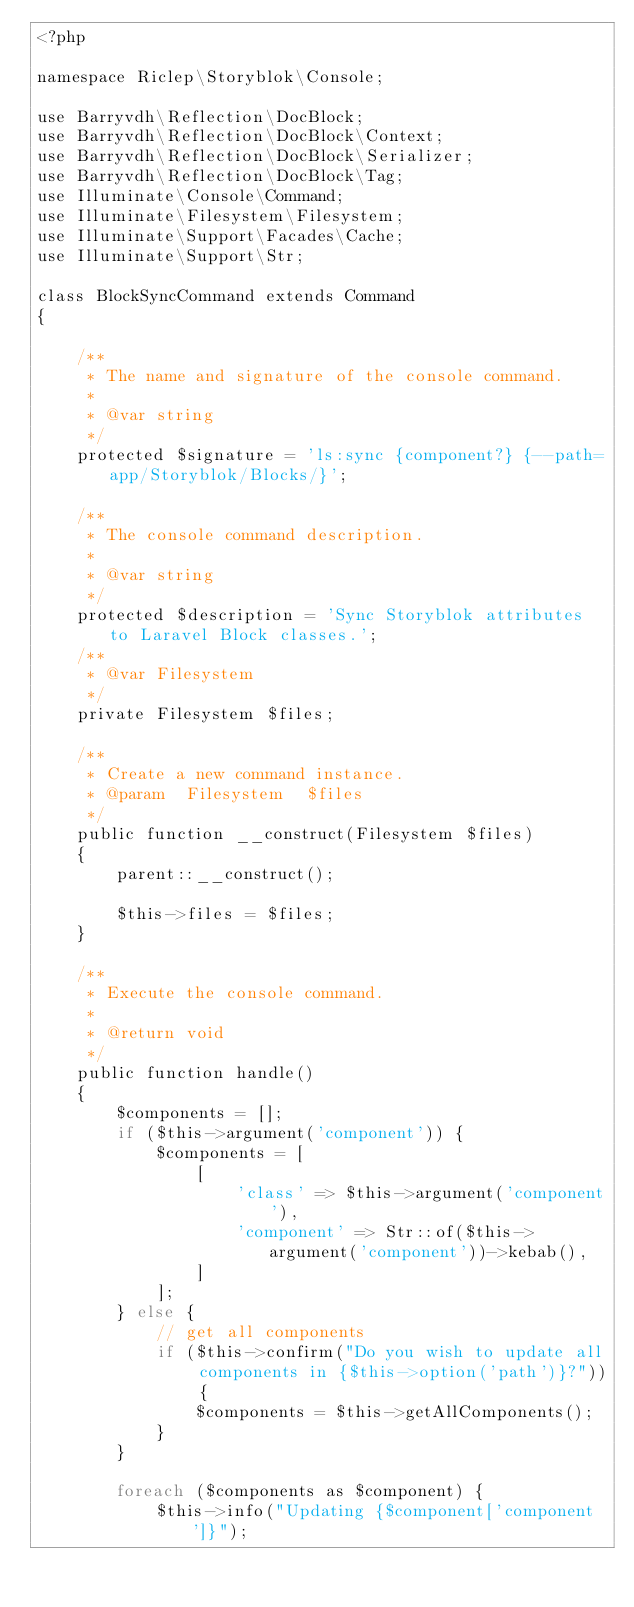<code> <loc_0><loc_0><loc_500><loc_500><_PHP_><?php

namespace Riclep\Storyblok\Console;

use Barryvdh\Reflection\DocBlock;
use Barryvdh\Reflection\DocBlock\Context;
use Barryvdh\Reflection\DocBlock\Serializer;
use Barryvdh\Reflection\DocBlock\Tag;
use Illuminate\Console\Command;
use Illuminate\Filesystem\Filesystem;
use Illuminate\Support\Facades\Cache;
use Illuminate\Support\Str;

class BlockSyncCommand extends Command
{

    /**
     * The name and signature of the console command.
     *
     * @var string
     */
    protected $signature = 'ls:sync {component?} {--path=app/Storyblok/Blocks/}';

    /**
     * The console command description.
     *
     * @var string
     */
    protected $description = 'Sync Storyblok attributes to Laravel Block classes.';
    /**
     * @var Filesystem
     */
    private Filesystem $files;

    /**
     * Create a new command instance.
     * @param  Filesystem  $files
     */
    public function __construct(Filesystem $files)
    {
        parent::__construct();

        $this->files = $files;
    }

    /**
     * Execute the console command.
     *
     * @return void
     */
    public function handle()
    {
        $components = [];
        if ($this->argument('component')) {
            $components = [
                [
                    'class' => $this->argument('component'),
                    'component' => Str::of($this->argument('component'))->kebab(),
                ]
            ];
        } else {
            // get all components
            if ($this->confirm("Do you wish to update all components in {$this->option('path')}?")) {
                $components = $this->getAllComponents();
            }
        }

        foreach ($components as $component) {
            $this->info("Updating {$component['component']}");</code> 